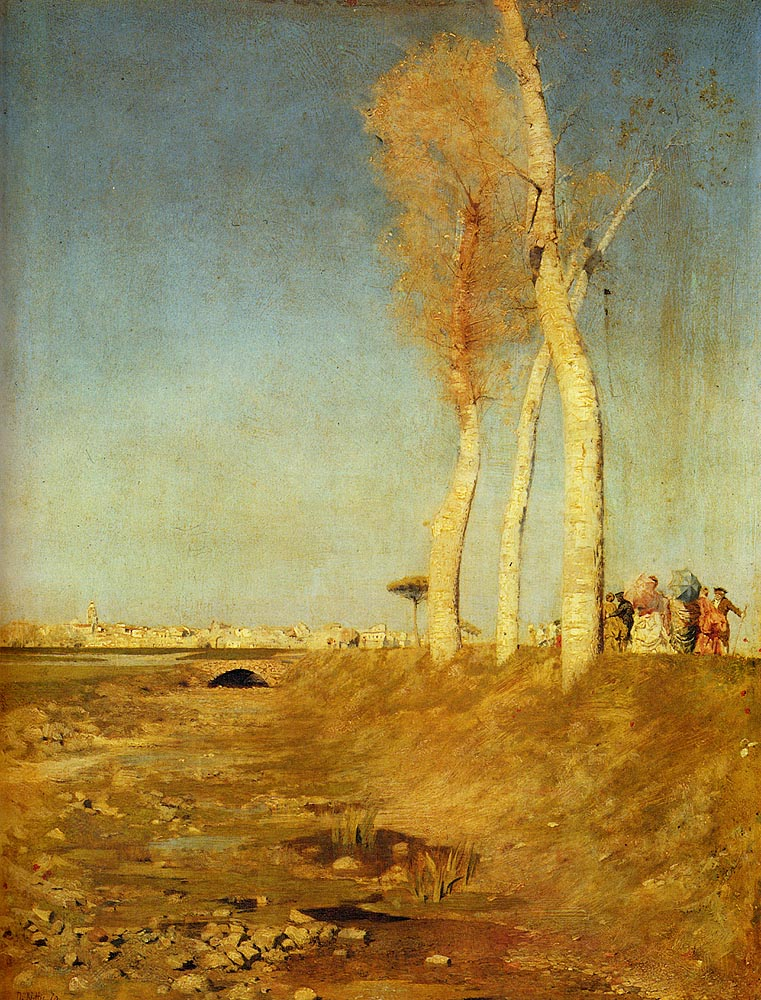How does the artist convey the impact of industrialization on the landscape? The artist subtly incorporates symbols of industrialization, like distant smokestacks, which are just visible against the horizon. This minimal yet powerful inclusion speaks to the creeping influence of industry, altering the serene rural setting. The choice of a subdued color palette for these elements suggests a critical perspective on this transformation, highlighting its silent but pervasive expansion into the natural environment. 